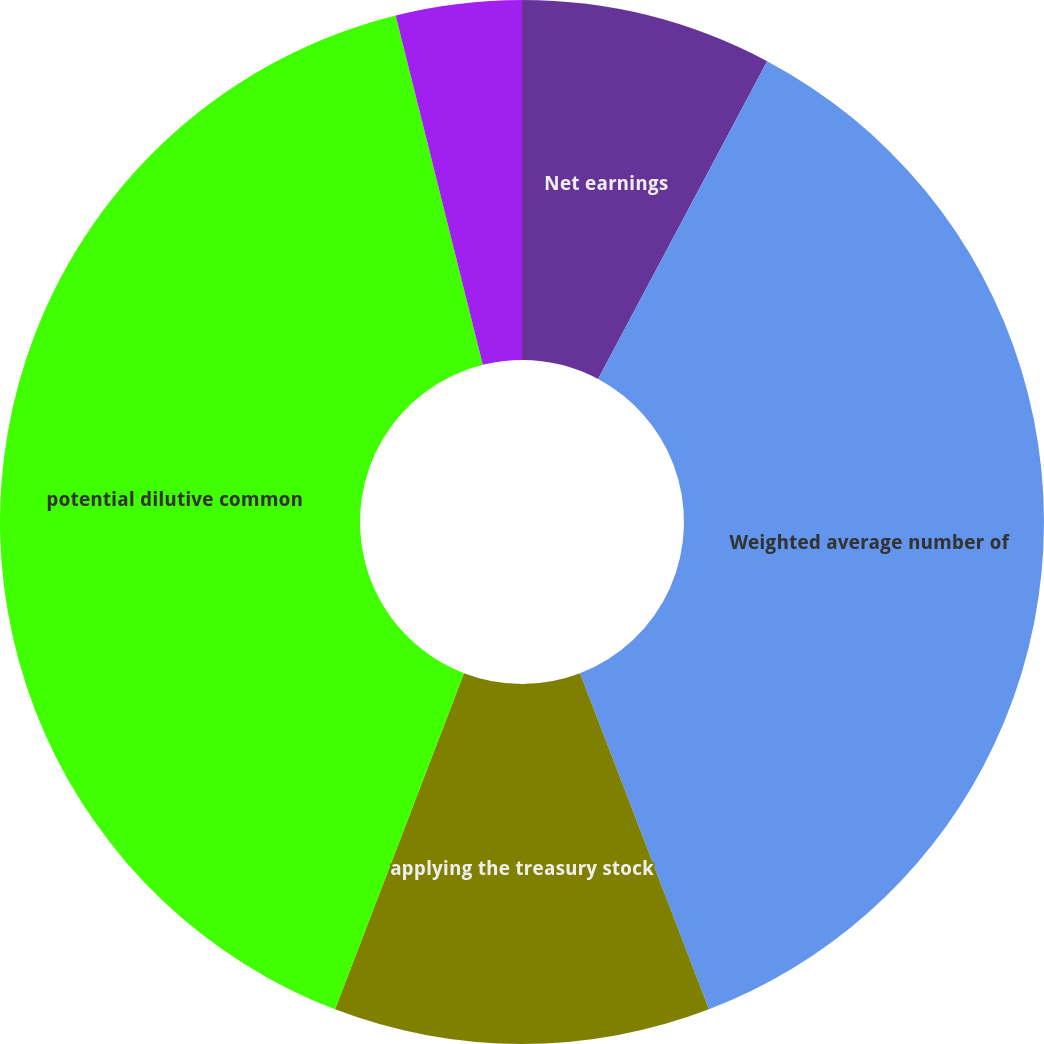Convert chart to OTSL. <chart><loc_0><loc_0><loc_500><loc_500><pie_chart><fcel>Net earnings<fcel>Weighted average number of<fcel>applying the treasury stock<fcel>potential dilutive common<fcel>Basic earnings per common<fcel>Diluted earnings per common<nl><fcel>7.78%<fcel>36.39%<fcel>11.66%<fcel>40.28%<fcel>3.89%<fcel>0.0%<nl></chart> 